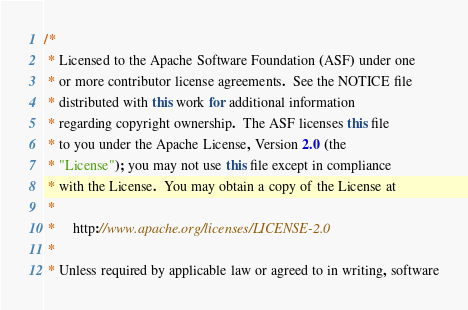<code> <loc_0><loc_0><loc_500><loc_500><_Java_>/*
 * Licensed to the Apache Software Foundation (ASF) under one
 * or more contributor license agreements.  See the NOTICE file
 * distributed with this work for additional information
 * regarding copyright ownership.  The ASF licenses this file
 * to you under the Apache License, Version 2.0 (the
 * "License"); you may not use this file except in compliance
 * with the License.  You may obtain a copy of the License at
 *
 *     http://www.apache.org/licenses/LICENSE-2.0
 *
 * Unless required by applicable law or agreed to in writing, software</code> 